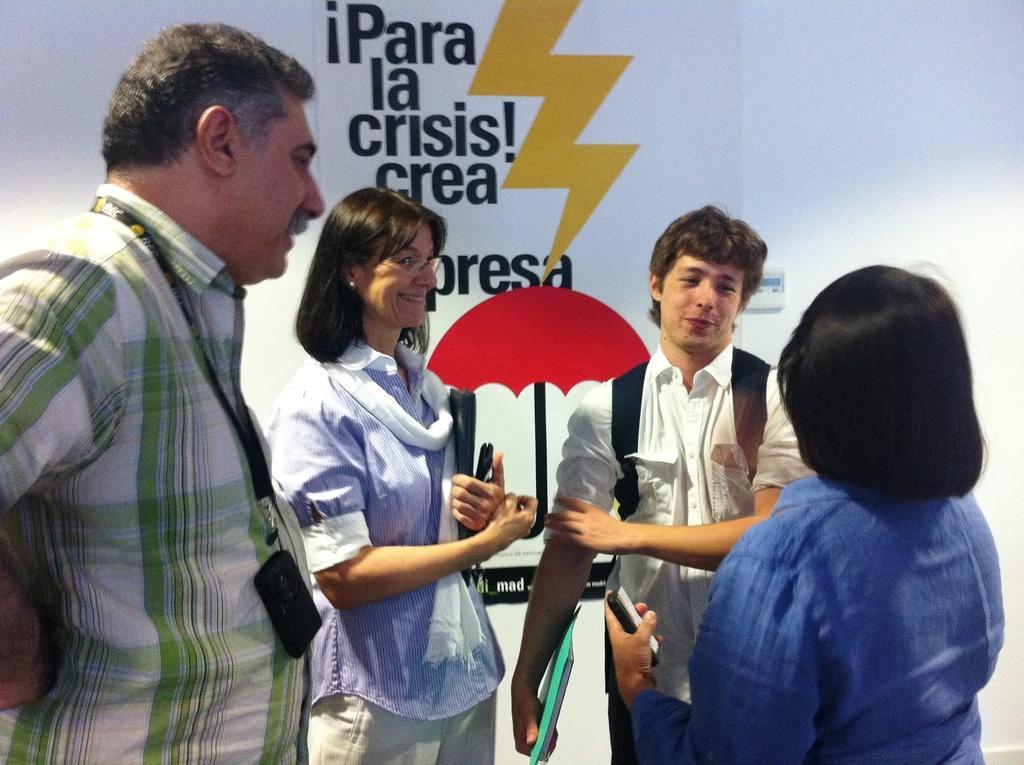In one or two sentences, can you explain what this image depicts? In this image we can see four persons. In the background we can see a poster on the wall. On the poster we can see picture of an umbrella and text written on it. 